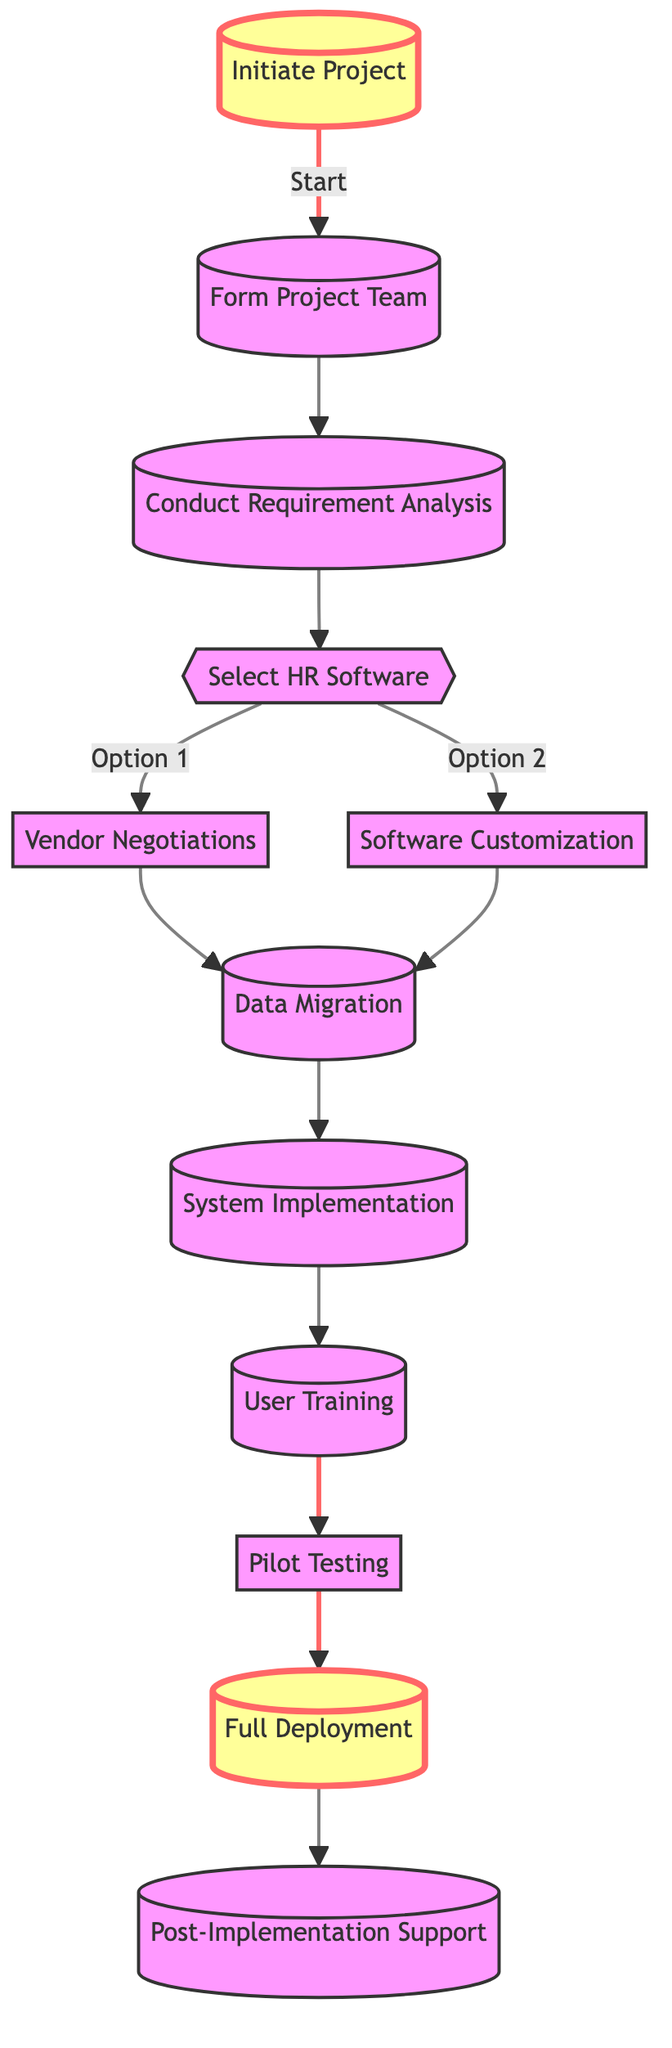What is the first step in the implementation process? The first step is "Initiate Project", which is clearly indicated as the starting point of the flow chart.
Answer: Initiate Project How many main steps are in the diagram? There are twelve main steps depicted in the flow chart from initiation to post-implementation support.
Answer: Twelve What comes after "Conduct Requirement Analysis"? After "Conduct Requirement Analysis," the next step is "Select HR Software," which directly follows in the sequence.
Answer: Select HR Software Which step involves discussions on pricing and terms? The step involving discussions on pricing and terms is "Vendor Negotiations," which is a subsequent step after selecting the HR software.
Answer: Vendor Negotiations What are the two options following "Select HR Software"? The two options that follow "Select HR Software" are "Vendor Negotiations" and "Software Customization," as shown by the branching in the diagram.
Answer: Vendor Negotiations and Software Customization What is the final step of the implementation process? The final step of the implementation process is "Post-Implementation Support," which is the last element in the flow chart.
Answer: Post-Implementation Support How many different paths are available after selecting HR software? There are two different paths available after selecting HR software, leading to either "Vendor Negotiations" or "Software Customization."
Answer: Two Which step requires providing ongoing support? The step that requires providing ongoing support is "Post-Implementation Support," as indicated clearly at the end of the flow chart.
Answer: Post-Implementation Support What is required before the "Full Deployment" step? Before the "Full Deployment" step, "Pilot Testing" is required to identify and resolve any issues, ensuring a smooth rollout.
Answer: Pilot Testing 